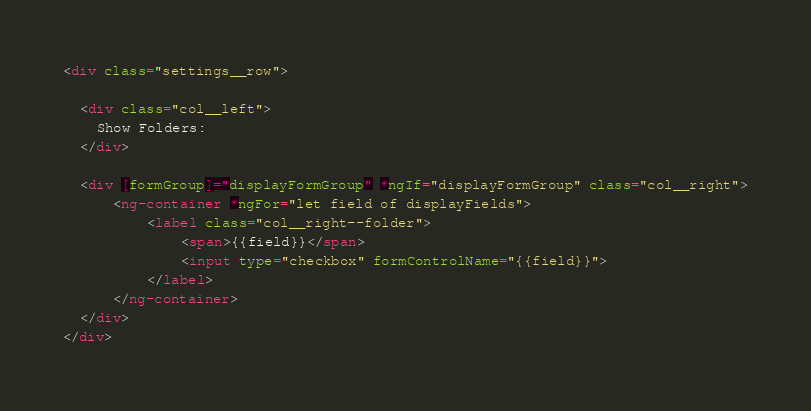<code> <loc_0><loc_0><loc_500><loc_500><_HTML_><div class="settings__row">

  <div class="col__left">
    Show Folders:
  </div>

  <div [formGroup]="displayFormGroup" *ngIf="displayFormGroup" class="col__right">
      <ng-container *ngFor="let field of displayFields">
          <label class="col__right--folder">
              <span>{{field}}</span>
              <input type="checkbox" formControlName="{{field}}">
          </label>
      </ng-container>
  </div>
</div>
</code> 